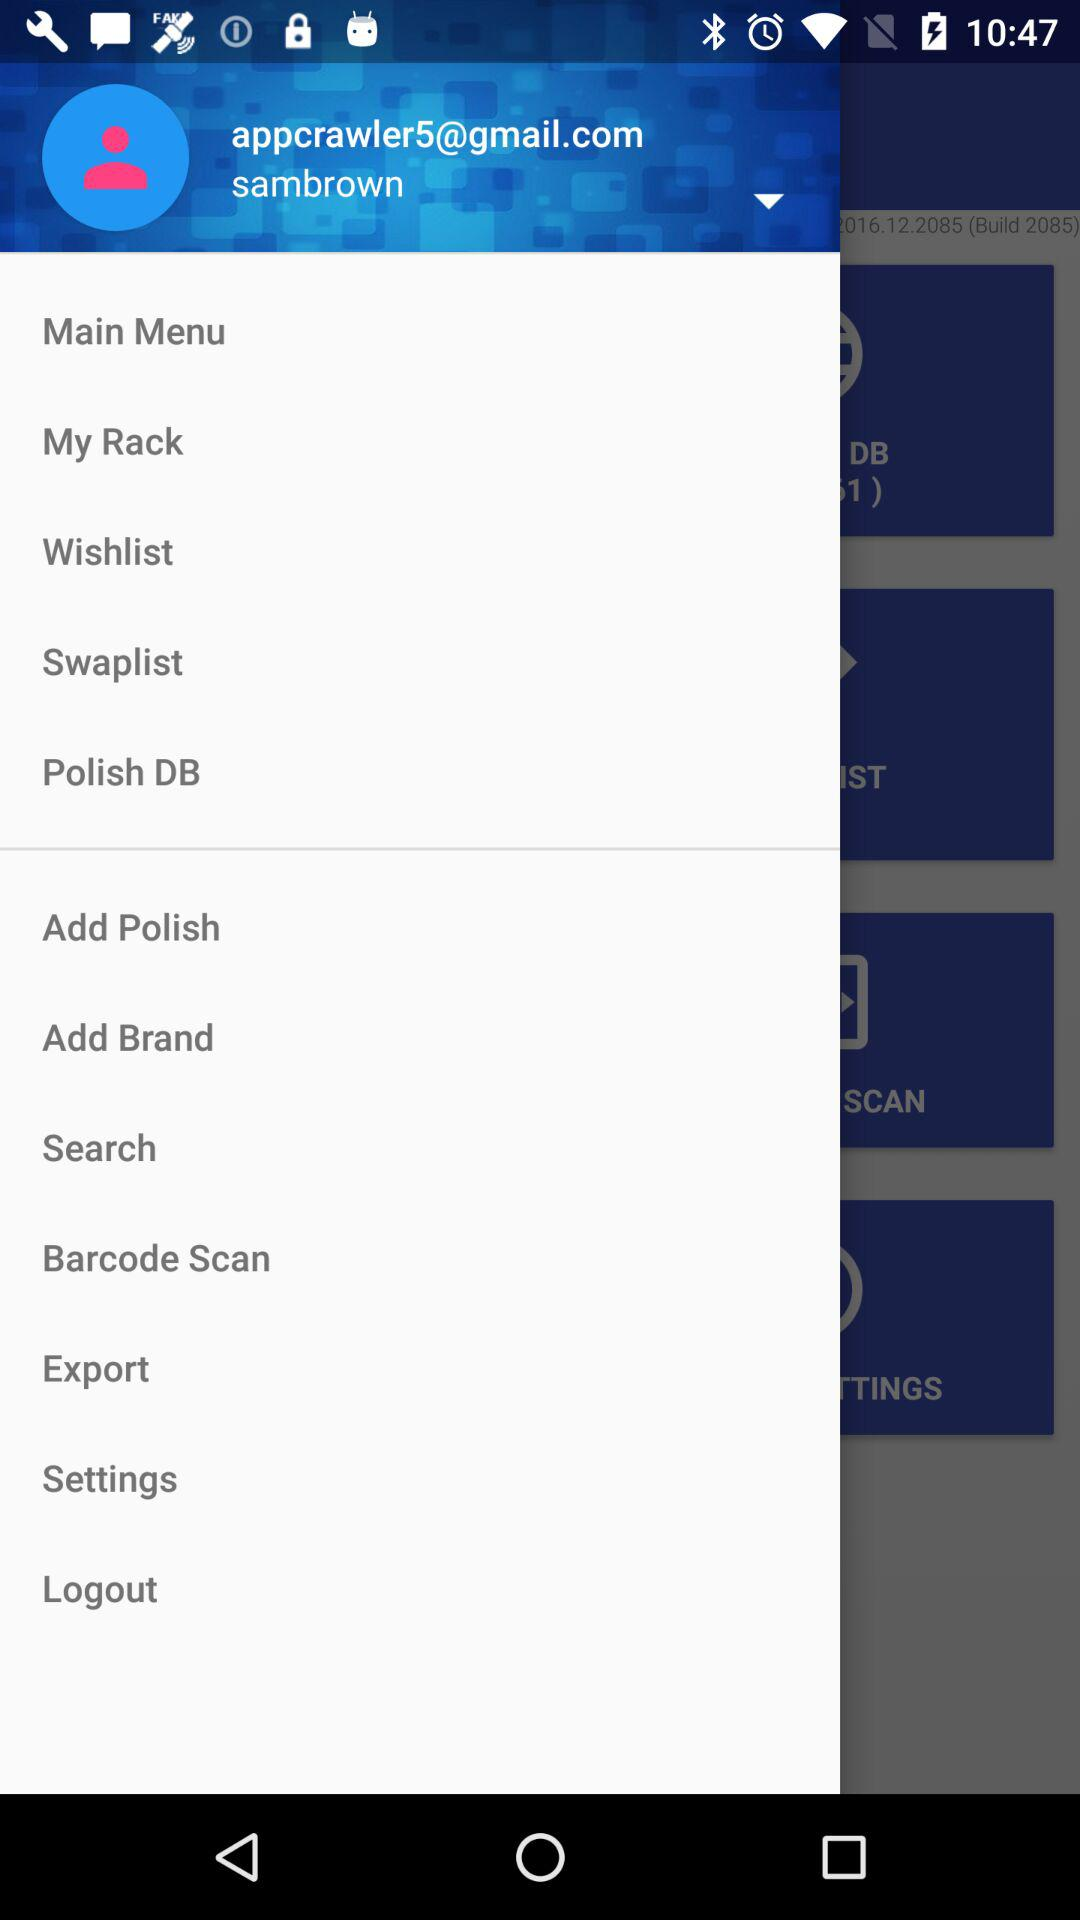What is the email address? The email address is appcrawler5@gmail.com. 